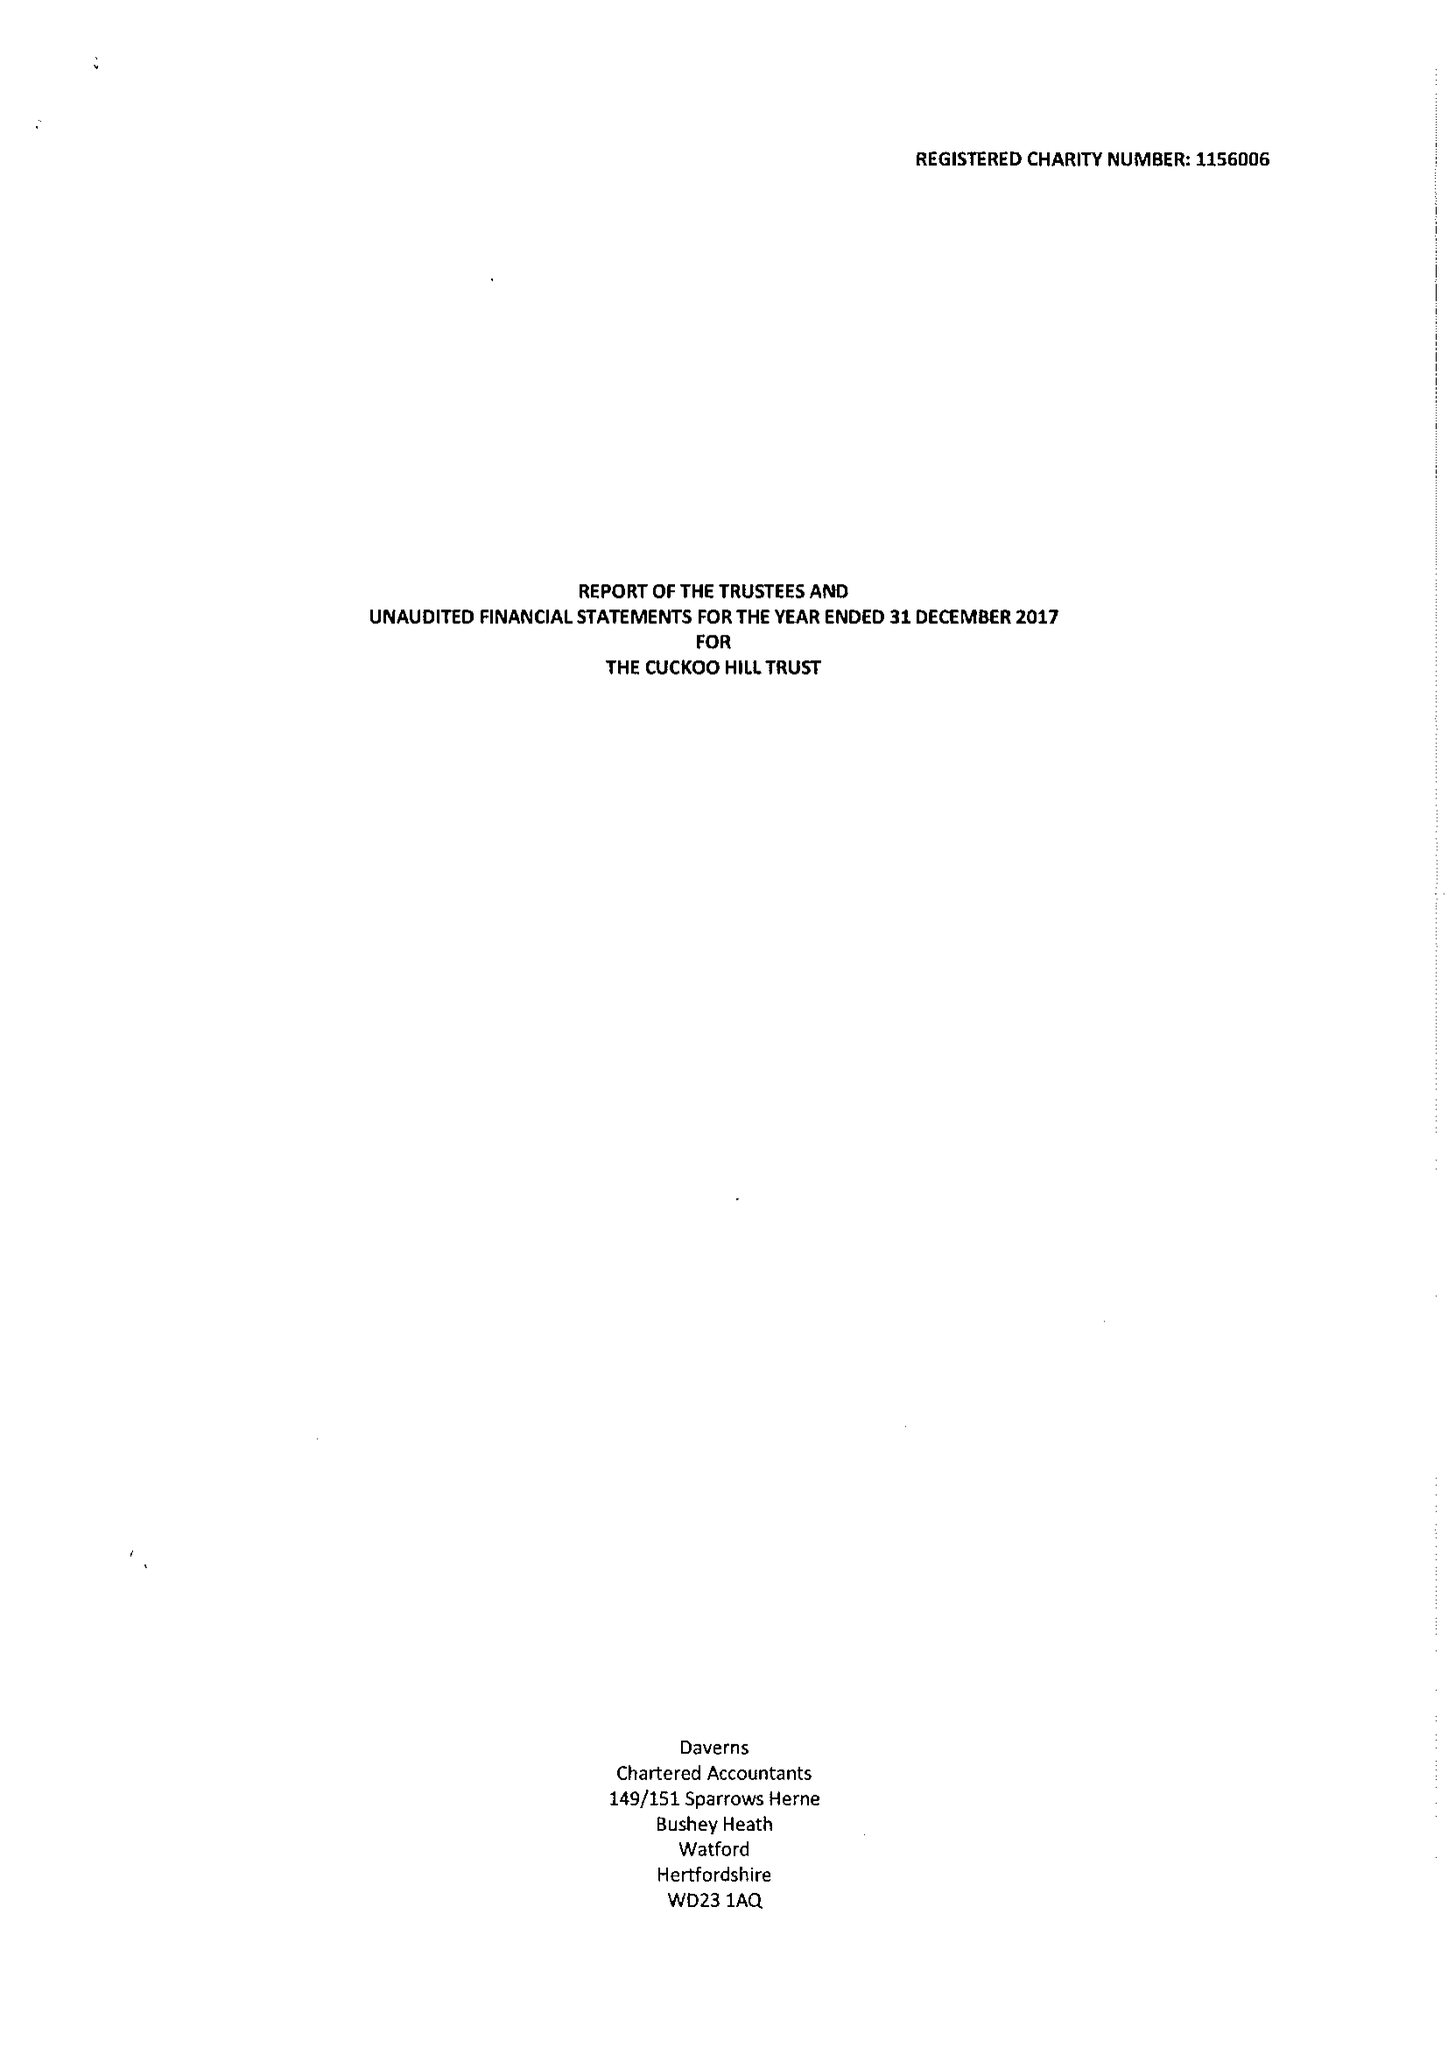What is the value for the address__post_town?
Answer the question using a single word or phrase. PINNER 